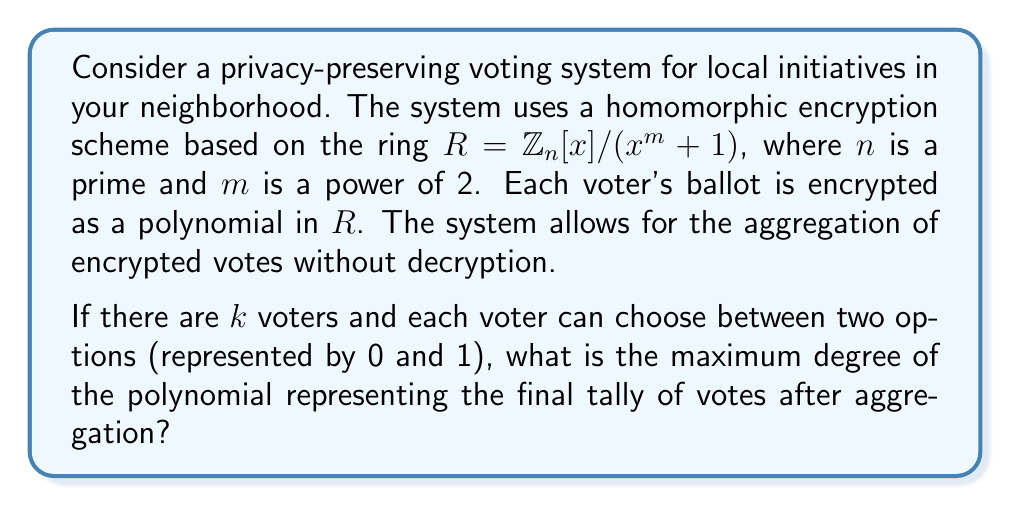Show me your answer to this math problem. To solve this problem, we need to understand the properties of the ring $R = \mathbb{Z}_n[x]/(x^m + 1)$ and how homomorphic encryption works in this context:

1) In the ring $R$, polynomials are reduced modulo $x^m + 1$, so the maximum degree of any polynomial in $R$ is $m-1$.

2) Each voter's ballot is encrypted as a polynomial in $R$. Let's say a vote for option 0 is encrypted as a polynomial $a(x)$, and a vote for option 1 is encrypted as $a(x) + 1$, where $a(x)$ is a random polynomial in $R$.

3) The homomorphic property allows us to add encrypted votes without decrypting them. This means we can add the polynomials representing each vote.

4) With $k$ voters, the final tally will be the sum of $k$ polynomials from $R$.

5) When we add polynomials, the degree of the result is at most the maximum of the degrees of the polynomials being added.

6) However, after each addition, the result is reduced modulo $x^m + 1$ in the ring $R$.

7) Therefore, regardless of how many votes we add, the degree of the resulting polynomial will always be at most $m-1$.

Thus, the maximum degree of the polynomial representing the final tally is $m-1$, independent of the number of voters $k$.
Answer: $m-1$ 